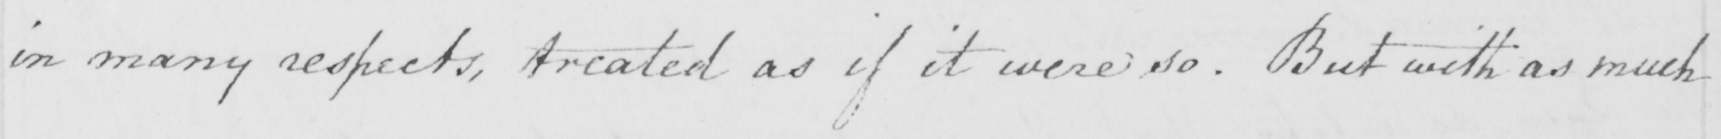What text is written in this handwritten line? in many respects , treated as if it were so . But with as much 